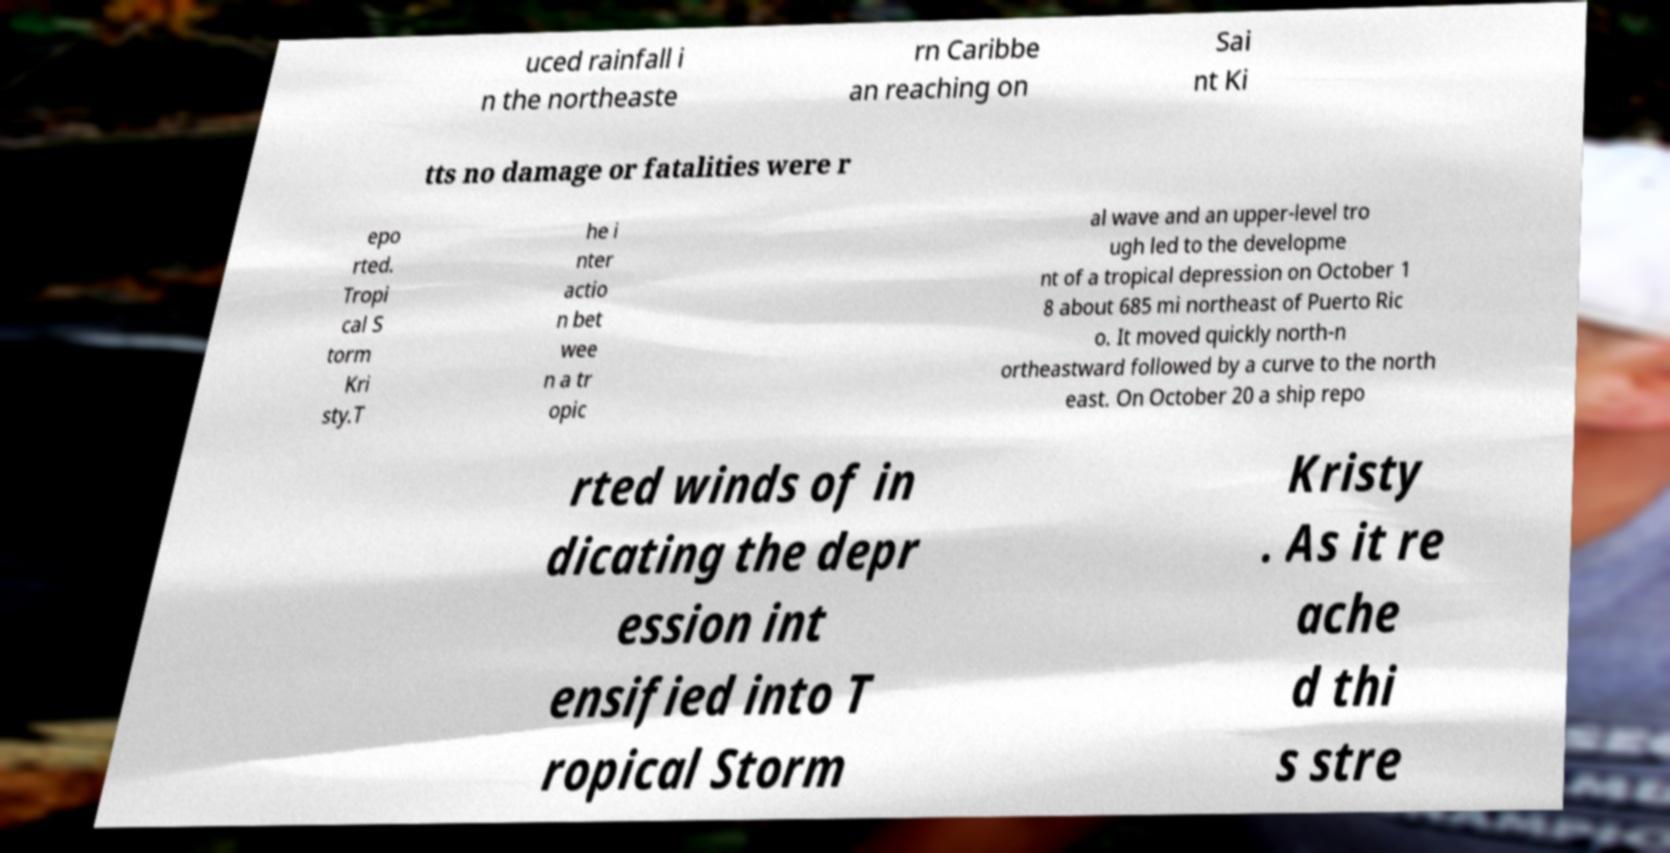Can you read and provide the text displayed in the image?This photo seems to have some interesting text. Can you extract and type it out for me? uced rainfall i n the northeaste rn Caribbe an reaching on Sai nt Ki tts no damage or fatalities were r epo rted. Tropi cal S torm Kri sty.T he i nter actio n bet wee n a tr opic al wave and an upper-level tro ugh led to the developme nt of a tropical depression on October 1 8 about 685 mi northeast of Puerto Ric o. It moved quickly north-n ortheastward followed by a curve to the north east. On October 20 a ship repo rted winds of in dicating the depr ession int ensified into T ropical Storm Kristy . As it re ache d thi s stre 